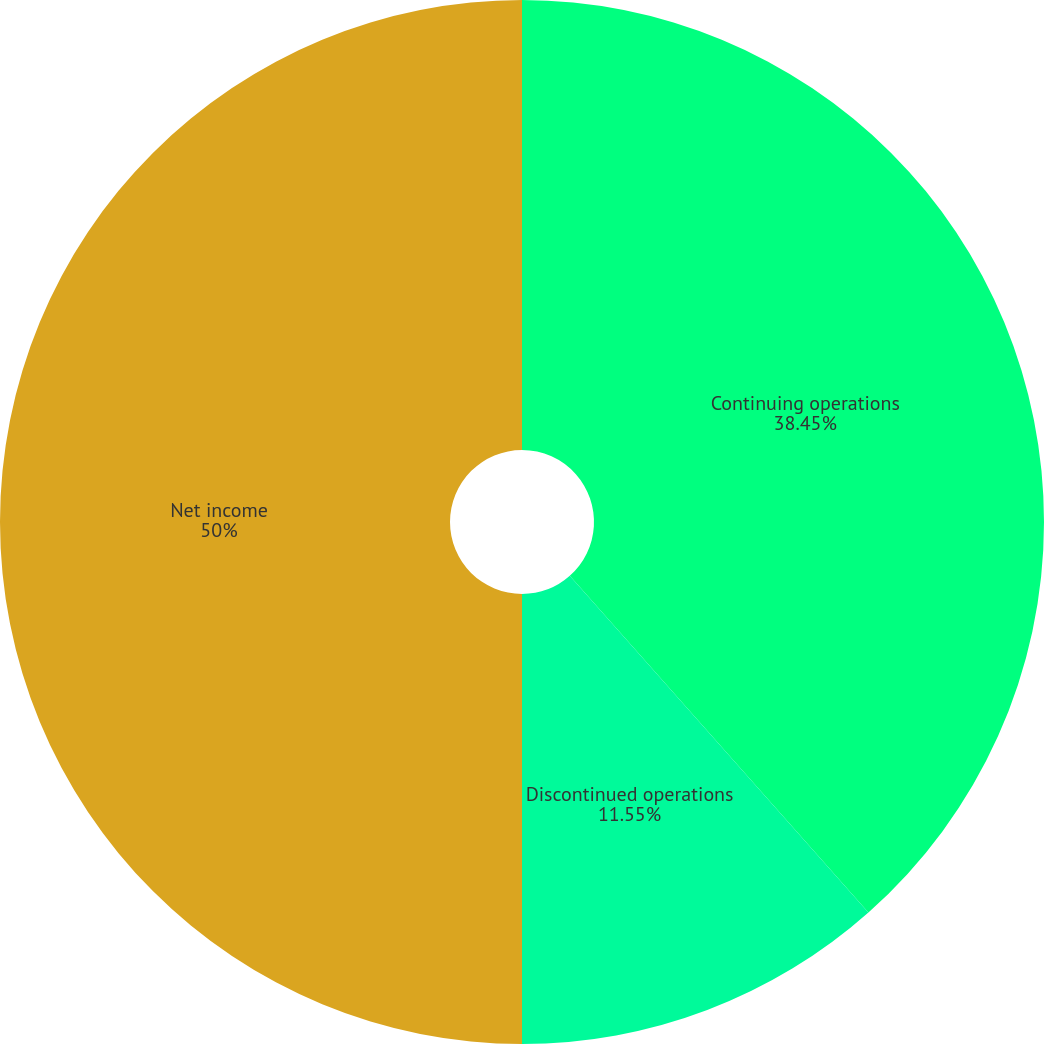<chart> <loc_0><loc_0><loc_500><loc_500><pie_chart><fcel>Continuing operations<fcel>Discontinued operations<fcel>Net income<nl><fcel>38.45%<fcel>11.55%<fcel>50.0%<nl></chart> 